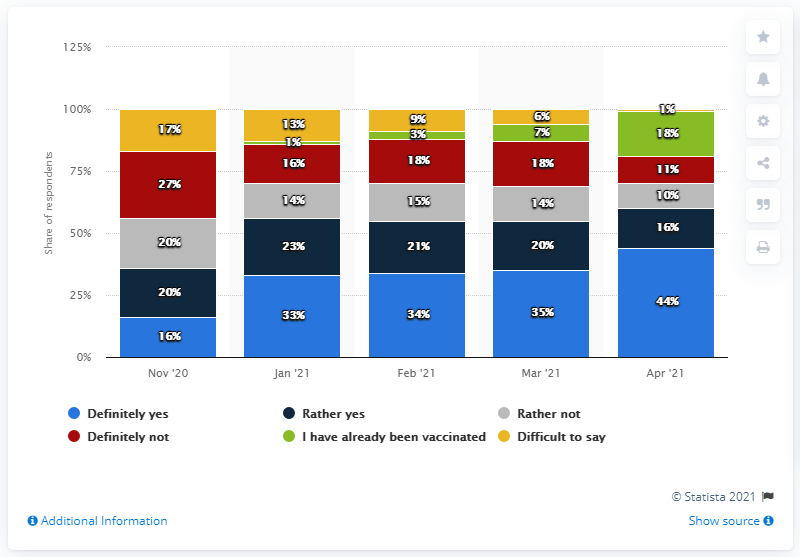Point out several critical features in this image. The difference between the highest value of 'definitely yes' and the lowest value of 'rather yes' on the Likert scale, ranging from 1 to 5, is 28. The highest value of the grey bar is 20. 